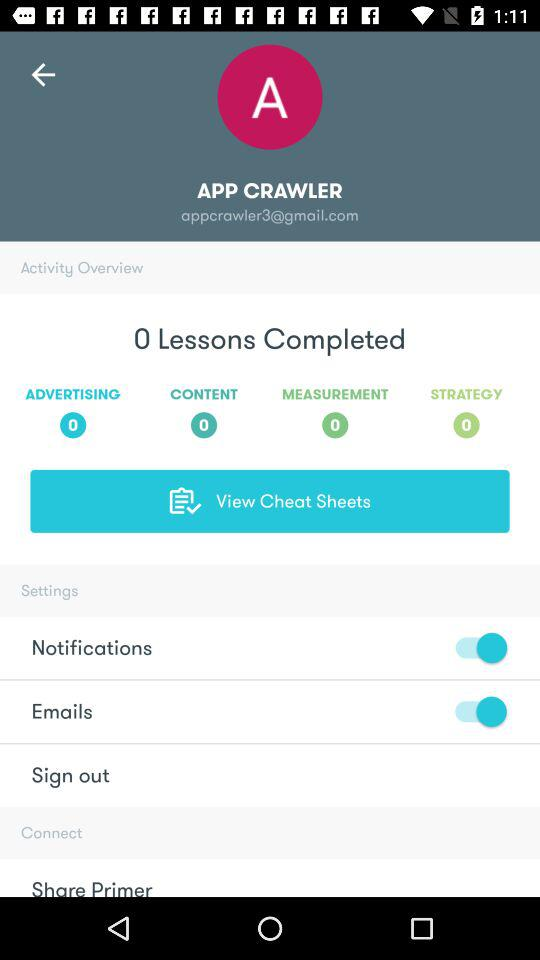What is the status of emails? The status is on. 